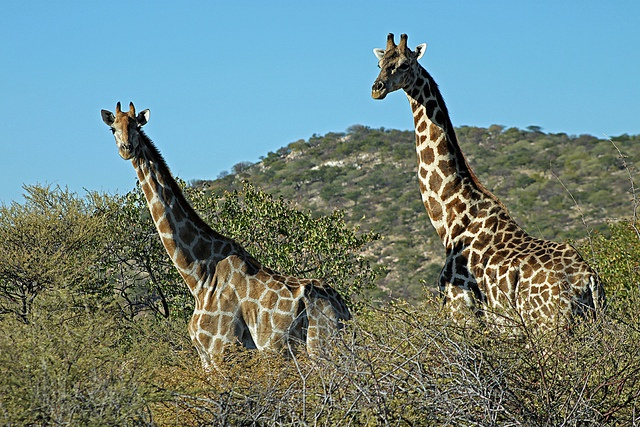Describe the objects in this image and their specific colors. I can see giraffe in lightblue, black, olive, tan, and beige tones and giraffe in lightblue, black, tan, gray, and olive tones in this image. 